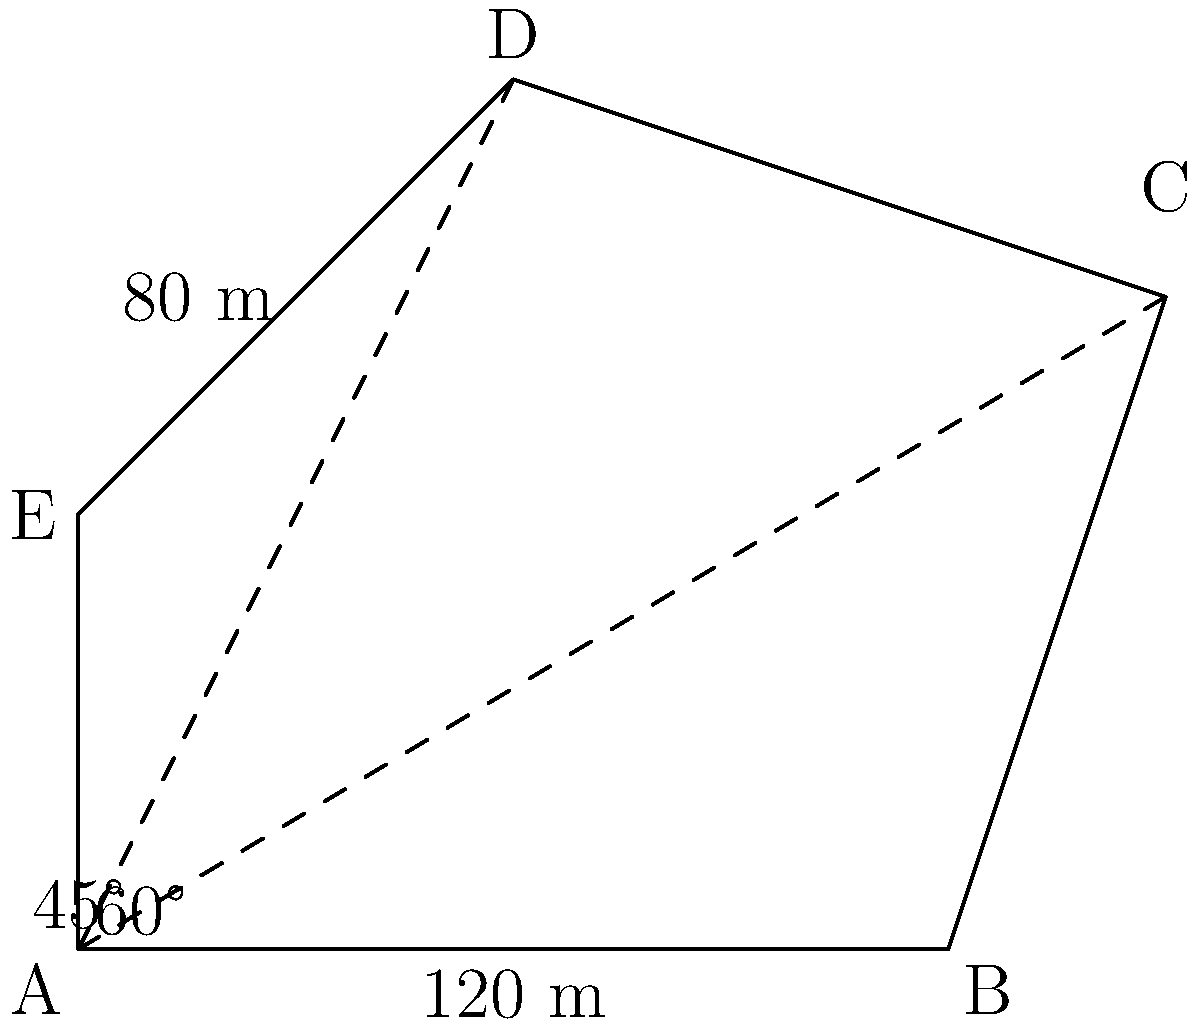In an aerial image, you've captured an irregularly shaped field ABCDE. Given that AB = 120 m, DE = 80 m, angle BAC = 60°, and angle DAE = 45°, calculate the area of the field using trigonometric functions. To find the area of the irregular field, we can divide it into triangles and use trigonometric functions. Let's break it down step-by-step:

1) First, divide the field into three triangles: ABC, ACD, and ADE.

2) For triangle ABC:
   - We know AB = 120 m and angle BAC = 60°
   - Area of ABC = $\frac{1}{2} \cdot AB \cdot AC \cdot \sin(60°)$
   - AC = $\frac{AB}{\cos(60°)} = \frac{120}{\frac{1}{2}} = 240$ m
   - Area of ABC = $\frac{1}{2} \cdot 120 \cdot 240 \cdot \frac{\sqrt{3}}{2} = 12600\sqrt{3}$ m²

3) For triangle ADE:
   - We know DE = 80 m and angle DAE = 45°
   - Area of ADE = $\frac{1}{2} \cdot DE \cdot AE \cdot \sin(45°)$
   - AE = $\frac{DE}{\sin(45°)} = \frac{80}{\frac{\sqrt{2}}{2}} = 80\sqrt{2}$ m
   - Area of ADE = $\frac{1}{2} \cdot 80 \cdot 80\sqrt{2} \cdot \frac{\sqrt{2}}{2} = 3200$ m²

4) For triangle ACD:
   - We need to find angle CAD = 180° - 60° - 45° = 75°
   - We know AC and AD from previous calculations
   - Area of ACD = $\frac{1}{2} \cdot AC \cdot AD \cdot \sin(75°)$
   - AD = $\frac{DE}{\cos(45°)} = \frac{80}{\frac{\sqrt{2}}{2}} = 80\sqrt{2}$ m
   - Area of ACD = $\frac{1}{2} \cdot 240 \cdot 80\sqrt{2} \cdot \sin(75°) = 9600\sqrt{2} \cdot \sin(75°)$ m²

5) Total area = Area of ABC + Area of ACD + Area of ADE
               = $12600\sqrt{3} + 9600\sqrt{2} \cdot \sin(75°) + 3200$ m²

6) Simplifying and calculating:
   Total area ≈ 21,840 + 13,093 + 3,200 = 38,133 m²
Answer: 38,133 m² 